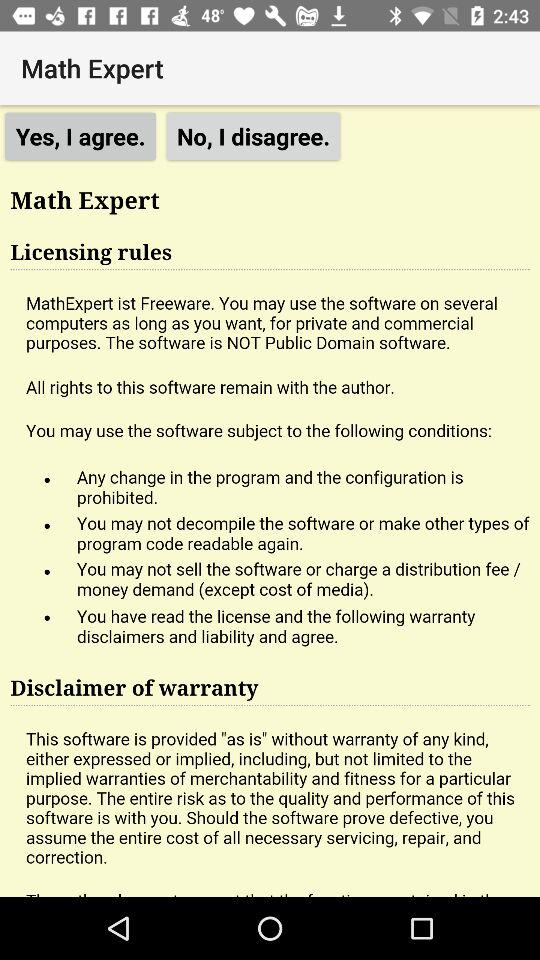How many warnings are there in the licensing rules?
Answer the question using a single word or phrase. 4 